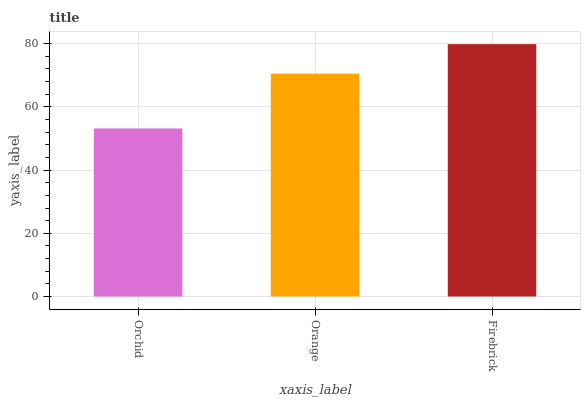Is Orchid the minimum?
Answer yes or no. Yes. Is Firebrick the maximum?
Answer yes or no. Yes. Is Orange the minimum?
Answer yes or no. No. Is Orange the maximum?
Answer yes or no. No. Is Orange greater than Orchid?
Answer yes or no. Yes. Is Orchid less than Orange?
Answer yes or no. Yes. Is Orchid greater than Orange?
Answer yes or no. No. Is Orange less than Orchid?
Answer yes or no. No. Is Orange the high median?
Answer yes or no. Yes. Is Orange the low median?
Answer yes or no. Yes. Is Orchid the high median?
Answer yes or no. No. Is Firebrick the low median?
Answer yes or no. No. 